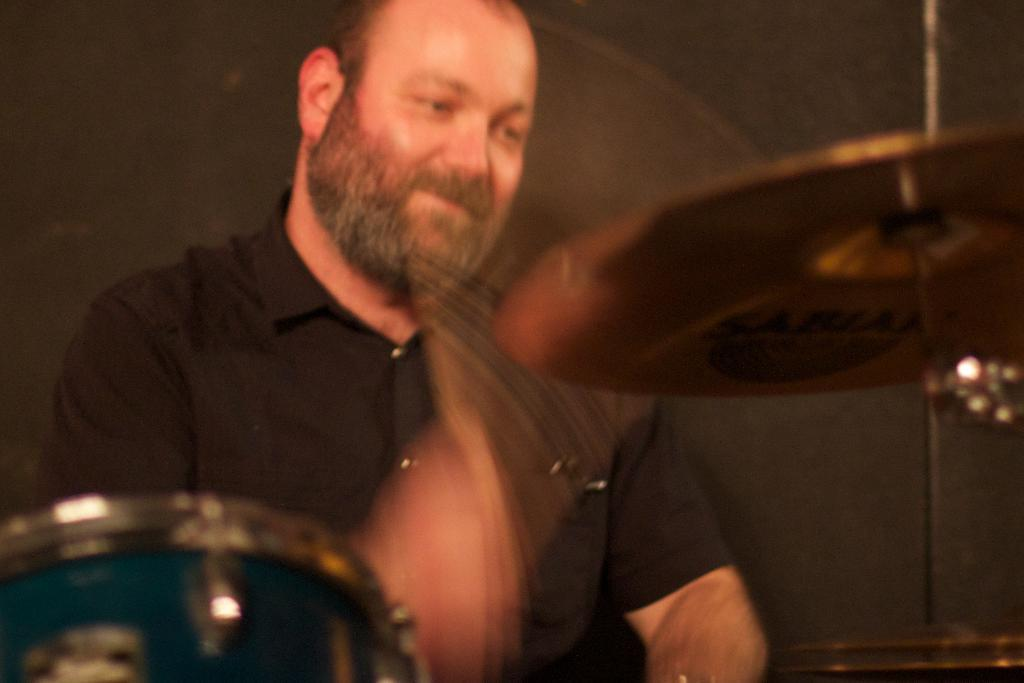What is the man in the image doing? The man is playing a drum. What is the man wearing in the image? The man is wearing a black shirt. What type of pest can be seen running across the drum in the image? There are no pests visible in the image, and the drum is not being used by any creature. 